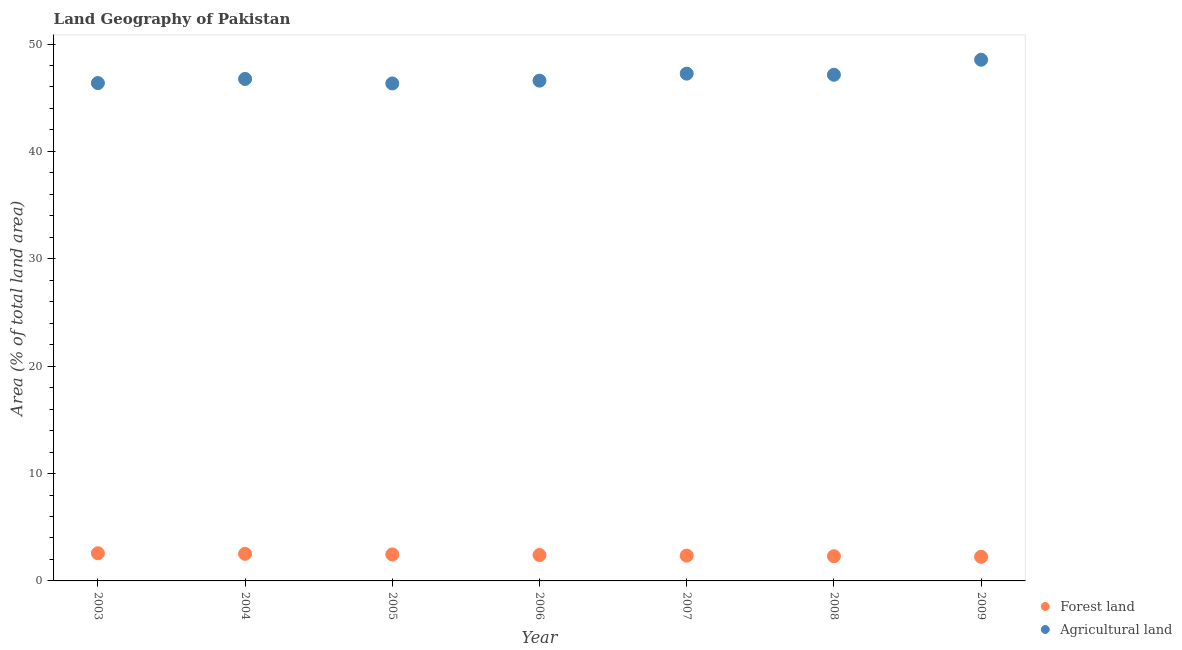How many different coloured dotlines are there?
Offer a very short reply. 2. Is the number of dotlines equal to the number of legend labels?
Make the answer very short. Yes. What is the percentage of land area under agriculture in 2006?
Ensure brevity in your answer.  46.59. Across all years, what is the maximum percentage of land area under agriculture?
Keep it short and to the point. 48.54. Across all years, what is the minimum percentage of land area under agriculture?
Make the answer very short. 46.33. What is the total percentage of land area under agriculture in the graph?
Keep it short and to the point. 328.94. What is the difference between the percentage of land area under agriculture in 2007 and that in 2009?
Your response must be concise. -1.3. What is the difference between the percentage of land area under agriculture in 2004 and the percentage of land area under forests in 2009?
Keep it short and to the point. 44.5. What is the average percentage of land area under forests per year?
Offer a terse response. 2.41. In the year 2009, what is the difference between the percentage of land area under forests and percentage of land area under agriculture?
Keep it short and to the point. -46.29. In how many years, is the percentage of land area under forests greater than 18 %?
Ensure brevity in your answer.  0. What is the ratio of the percentage of land area under agriculture in 2005 to that in 2006?
Your answer should be compact. 0.99. Is the difference between the percentage of land area under agriculture in 2003 and 2009 greater than the difference between the percentage of land area under forests in 2003 and 2009?
Ensure brevity in your answer.  No. What is the difference between the highest and the second highest percentage of land area under forests?
Your response must be concise. 0.06. What is the difference between the highest and the lowest percentage of land area under agriculture?
Your response must be concise. 2.21. Is the percentage of land area under agriculture strictly less than the percentage of land area under forests over the years?
Provide a succinct answer. No. How many dotlines are there?
Make the answer very short. 2. What is the difference between two consecutive major ticks on the Y-axis?
Your answer should be compact. 10. Does the graph contain any zero values?
Keep it short and to the point. No. Does the graph contain grids?
Ensure brevity in your answer.  No. What is the title of the graph?
Offer a terse response. Land Geography of Pakistan. Does "Age 65(male)" appear as one of the legend labels in the graph?
Make the answer very short. No. What is the label or title of the X-axis?
Your answer should be compact. Year. What is the label or title of the Y-axis?
Provide a short and direct response. Area (% of total land area). What is the Area (% of total land area) of Forest land in 2003?
Provide a short and direct response. 2.58. What is the Area (% of total land area) in Agricultural land in 2003?
Ensure brevity in your answer.  46.36. What is the Area (% of total land area) of Forest land in 2004?
Provide a short and direct response. 2.52. What is the Area (% of total land area) of Agricultural land in 2004?
Keep it short and to the point. 46.75. What is the Area (% of total land area) in Forest land in 2005?
Give a very brief answer. 2.47. What is the Area (% of total land area) of Agricultural land in 2005?
Your answer should be very brief. 46.33. What is the Area (% of total land area) in Forest land in 2006?
Ensure brevity in your answer.  2.41. What is the Area (% of total land area) of Agricultural land in 2006?
Ensure brevity in your answer.  46.59. What is the Area (% of total land area) in Forest land in 2007?
Provide a succinct answer. 2.36. What is the Area (% of total land area) in Agricultural land in 2007?
Offer a terse response. 47.24. What is the Area (% of total land area) of Forest land in 2008?
Offer a terse response. 2.3. What is the Area (% of total land area) in Agricultural land in 2008?
Your answer should be compact. 47.14. What is the Area (% of total land area) in Forest land in 2009?
Provide a short and direct response. 2.24. What is the Area (% of total land area) in Agricultural land in 2009?
Provide a succinct answer. 48.54. Across all years, what is the maximum Area (% of total land area) in Forest land?
Provide a succinct answer. 2.58. Across all years, what is the maximum Area (% of total land area) in Agricultural land?
Provide a short and direct response. 48.54. Across all years, what is the minimum Area (% of total land area) of Forest land?
Your response must be concise. 2.24. Across all years, what is the minimum Area (% of total land area) of Agricultural land?
Provide a succinct answer. 46.33. What is the total Area (% of total land area) of Forest land in the graph?
Your answer should be compact. 16.88. What is the total Area (% of total land area) in Agricultural land in the graph?
Keep it short and to the point. 328.94. What is the difference between the Area (% of total land area) in Forest land in 2003 and that in 2004?
Offer a very short reply. 0.06. What is the difference between the Area (% of total land area) of Agricultural land in 2003 and that in 2004?
Your answer should be very brief. -0.38. What is the difference between the Area (% of total land area) in Forest land in 2003 and that in 2005?
Ensure brevity in your answer.  0.11. What is the difference between the Area (% of total land area) of Agricultural land in 2003 and that in 2005?
Give a very brief answer. 0.04. What is the difference between the Area (% of total land area) in Forest land in 2003 and that in 2006?
Give a very brief answer. 0.17. What is the difference between the Area (% of total land area) of Agricultural land in 2003 and that in 2006?
Offer a very short reply. -0.22. What is the difference between the Area (% of total land area) in Forest land in 2003 and that in 2007?
Your answer should be very brief. 0.22. What is the difference between the Area (% of total land area) of Agricultural land in 2003 and that in 2007?
Your response must be concise. -0.88. What is the difference between the Area (% of total land area) in Forest land in 2003 and that in 2008?
Provide a short and direct response. 0.28. What is the difference between the Area (% of total land area) of Agricultural land in 2003 and that in 2008?
Ensure brevity in your answer.  -0.77. What is the difference between the Area (% of total land area) of Forest land in 2003 and that in 2009?
Make the answer very short. 0.33. What is the difference between the Area (% of total land area) in Agricultural land in 2003 and that in 2009?
Give a very brief answer. -2.17. What is the difference between the Area (% of total land area) in Forest land in 2004 and that in 2005?
Your response must be concise. 0.06. What is the difference between the Area (% of total land area) in Agricultural land in 2004 and that in 2005?
Provide a short and direct response. 0.42. What is the difference between the Area (% of total land area) in Forest land in 2004 and that in 2006?
Offer a terse response. 0.11. What is the difference between the Area (% of total land area) in Agricultural land in 2004 and that in 2006?
Make the answer very short. 0.16. What is the difference between the Area (% of total land area) of Forest land in 2004 and that in 2007?
Make the answer very short. 0.17. What is the difference between the Area (% of total land area) in Agricultural land in 2004 and that in 2007?
Provide a short and direct response. -0.5. What is the difference between the Area (% of total land area) of Forest land in 2004 and that in 2008?
Your response must be concise. 0.22. What is the difference between the Area (% of total land area) of Agricultural land in 2004 and that in 2008?
Make the answer very short. -0.39. What is the difference between the Area (% of total land area) of Forest land in 2004 and that in 2009?
Your answer should be compact. 0.28. What is the difference between the Area (% of total land area) of Agricultural land in 2004 and that in 2009?
Provide a succinct answer. -1.79. What is the difference between the Area (% of total land area) of Forest land in 2005 and that in 2006?
Give a very brief answer. 0.06. What is the difference between the Area (% of total land area) in Agricultural land in 2005 and that in 2006?
Offer a very short reply. -0.26. What is the difference between the Area (% of total land area) of Forest land in 2005 and that in 2007?
Provide a short and direct response. 0.11. What is the difference between the Area (% of total land area) of Agricultural land in 2005 and that in 2007?
Offer a terse response. -0.91. What is the difference between the Area (% of total land area) of Forest land in 2005 and that in 2008?
Offer a terse response. 0.17. What is the difference between the Area (% of total land area) of Agricultural land in 2005 and that in 2008?
Offer a terse response. -0.81. What is the difference between the Area (% of total land area) in Forest land in 2005 and that in 2009?
Your response must be concise. 0.22. What is the difference between the Area (% of total land area) of Agricultural land in 2005 and that in 2009?
Offer a very short reply. -2.21. What is the difference between the Area (% of total land area) in Forest land in 2006 and that in 2007?
Keep it short and to the point. 0.06. What is the difference between the Area (% of total land area) in Agricultural land in 2006 and that in 2007?
Provide a succinct answer. -0.65. What is the difference between the Area (% of total land area) of Forest land in 2006 and that in 2008?
Provide a short and direct response. 0.11. What is the difference between the Area (% of total land area) in Agricultural land in 2006 and that in 2008?
Keep it short and to the point. -0.55. What is the difference between the Area (% of total land area) in Forest land in 2006 and that in 2009?
Give a very brief answer. 0.17. What is the difference between the Area (% of total land area) of Agricultural land in 2006 and that in 2009?
Offer a terse response. -1.95. What is the difference between the Area (% of total land area) of Forest land in 2007 and that in 2008?
Make the answer very short. 0.06. What is the difference between the Area (% of total land area) in Agricultural land in 2007 and that in 2008?
Make the answer very short. 0.1. What is the difference between the Area (% of total land area) in Forest land in 2007 and that in 2009?
Offer a terse response. 0.11. What is the difference between the Area (% of total land area) in Agricultural land in 2007 and that in 2009?
Offer a terse response. -1.3. What is the difference between the Area (% of total land area) of Forest land in 2008 and that in 2009?
Your answer should be compact. 0.06. What is the difference between the Area (% of total land area) of Agricultural land in 2008 and that in 2009?
Make the answer very short. -1.4. What is the difference between the Area (% of total land area) in Forest land in 2003 and the Area (% of total land area) in Agricultural land in 2004?
Keep it short and to the point. -44.17. What is the difference between the Area (% of total land area) of Forest land in 2003 and the Area (% of total land area) of Agricultural land in 2005?
Ensure brevity in your answer.  -43.75. What is the difference between the Area (% of total land area) of Forest land in 2003 and the Area (% of total land area) of Agricultural land in 2006?
Make the answer very short. -44.01. What is the difference between the Area (% of total land area) of Forest land in 2003 and the Area (% of total land area) of Agricultural land in 2007?
Your answer should be very brief. -44.66. What is the difference between the Area (% of total land area) in Forest land in 2003 and the Area (% of total land area) in Agricultural land in 2008?
Provide a short and direct response. -44.56. What is the difference between the Area (% of total land area) in Forest land in 2003 and the Area (% of total land area) in Agricultural land in 2009?
Your response must be concise. -45.96. What is the difference between the Area (% of total land area) in Forest land in 2004 and the Area (% of total land area) in Agricultural land in 2005?
Offer a terse response. -43.8. What is the difference between the Area (% of total land area) of Forest land in 2004 and the Area (% of total land area) of Agricultural land in 2006?
Your answer should be compact. -44.06. What is the difference between the Area (% of total land area) in Forest land in 2004 and the Area (% of total land area) in Agricultural land in 2007?
Your response must be concise. -44.72. What is the difference between the Area (% of total land area) in Forest land in 2004 and the Area (% of total land area) in Agricultural land in 2008?
Your answer should be very brief. -44.61. What is the difference between the Area (% of total land area) of Forest land in 2004 and the Area (% of total land area) of Agricultural land in 2009?
Your response must be concise. -46.01. What is the difference between the Area (% of total land area) in Forest land in 2005 and the Area (% of total land area) in Agricultural land in 2006?
Offer a very short reply. -44.12. What is the difference between the Area (% of total land area) of Forest land in 2005 and the Area (% of total land area) of Agricultural land in 2007?
Your response must be concise. -44.77. What is the difference between the Area (% of total land area) of Forest land in 2005 and the Area (% of total land area) of Agricultural land in 2008?
Give a very brief answer. -44.67. What is the difference between the Area (% of total land area) in Forest land in 2005 and the Area (% of total land area) in Agricultural land in 2009?
Your answer should be very brief. -46.07. What is the difference between the Area (% of total land area) of Forest land in 2006 and the Area (% of total land area) of Agricultural land in 2007?
Offer a very short reply. -44.83. What is the difference between the Area (% of total land area) in Forest land in 2006 and the Area (% of total land area) in Agricultural land in 2008?
Offer a very short reply. -44.73. What is the difference between the Area (% of total land area) in Forest land in 2006 and the Area (% of total land area) in Agricultural land in 2009?
Provide a succinct answer. -46.13. What is the difference between the Area (% of total land area) of Forest land in 2007 and the Area (% of total land area) of Agricultural land in 2008?
Offer a very short reply. -44.78. What is the difference between the Area (% of total land area) of Forest land in 2007 and the Area (% of total land area) of Agricultural land in 2009?
Make the answer very short. -46.18. What is the difference between the Area (% of total land area) in Forest land in 2008 and the Area (% of total land area) in Agricultural land in 2009?
Ensure brevity in your answer.  -46.24. What is the average Area (% of total land area) of Forest land per year?
Provide a succinct answer. 2.41. What is the average Area (% of total land area) in Agricultural land per year?
Your response must be concise. 46.99. In the year 2003, what is the difference between the Area (% of total land area) of Forest land and Area (% of total land area) of Agricultural land?
Offer a terse response. -43.78. In the year 2004, what is the difference between the Area (% of total land area) in Forest land and Area (% of total land area) in Agricultural land?
Your answer should be very brief. -44.22. In the year 2005, what is the difference between the Area (% of total land area) in Forest land and Area (% of total land area) in Agricultural land?
Offer a terse response. -43.86. In the year 2006, what is the difference between the Area (% of total land area) of Forest land and Area (% of total land area) of Agricultural land?
Your response must be concise. -44.18. In the year 2007, what is the difference between the Area (% of total land area) of Forest land and Area (% of total land area) of Agricultural land?
Offer a very short reply. -44.89. In the year 2008, what is the difference between the Area (% of total land area) of Forest land and Area (% of total land area) of Agricultural land?
Your answer should be compact. -44.84. In the year 2009, what is the difference between the Area (% of total land area) of Forest land and Area (% of total land area) of Agricultural land?
Provide a succinct answer. -46.29. What is the ratio of the Area (% of total land area) in Forest land in 2003 to that in 2005?
Offer a very short reply. 1.04. What is the ratio of the Area (% of total land area) of Agricultural land in 2003 to that in 2005?
Provide a short and direct response. 1. What is the ratio of the Area (% of total land area) of Forest land in 2003 to that in 2006?
Keep it short and to the point. 1.07. What is the ratio of the Area (% of total land area) in Forest land in 2003 to that in 2007?
Offer a terse response. 1.09. What is the ratio of the Area (% of total land area) of Agricultural land in 2003 to that in 2007?
Your response must be concise. 0.98. What is the ratio of the Area (% of total land area) in Forest land in 2003 to that in 2008?
Keep it short and to the point. 1.12. What is the ratio of the Area (% of total land area) of Agricultural land in 2003 to that in 2008?
Provide a short and direct response. 0.98. What is the ratio of the Area (% of total land area) in Forest land in 2003 to that in 2009?
Your answer should be compact. 1.15. What is the ratio of the Area (% of total land area) of Agricultural land in 2003 to that in 2009?
Your answer should be compact. 0.96. What is the ratio of the Area (% of total land area) in Forest land in 2004 to that in 2005?
Provide a succinct answer. 1.02. What is the ratio of the Area (% of total land area) in Forest land in 2004 to that in 2006?
Your answer should be compact. 1.05. What is the ratio of the Area (% of total land area) of Agricultural land in 2004 to that in 2006?
Provide a succinct answer. 1. What is the ratio of the Area (% of total land area) in Forest land in 2004 to that in 2007?
Offer a very short reply. 1.07. What is the ratio of the Area (% of total land area) in Forest land in 2004 to that in 2008?
Keep it short and to the point. 1.1. What is the ratio of the Area (% of total land area) in Agricultural land in 2004 to that in 2008?
Provide a succinct answer. 0.99. What is the ratio of the Area (% of total land area) of Forest land in 2004 to that in 2009?
Provide a short and direct response. 1.12. What is the ratio of the Area (% of total land area) in Agricultural land in 2004 to that in 2009?
Ensure brevity in your answer.  0.96. What is the ratio of the Area (% of total land area) of Forest land in 2005 to that in 2006?
Offer a very short reply. 1.02. What is the ratio of the Area (% of total land area) in Agricultural land in 2005 to that in 2006?
Give a very brief answer. 0.99. What is the ratio of the Area (% of total land area) in Forest land in 2005 to that in 2007?
Your answer should be compact. 1.05. What is the ratio of the Area (% of total land area) in Agricultural land in 2005 to that in 2007?
Ensure brevity in your answer.  0.98. What is the ratio of the Area (% of total land area) in Forest land in 2005 to that in 2008?
Offer a terse response. 1.07. What is the ratio of the Area (% of total land area) in Agricultural land in 2005 to that in 2008?
Give a very brief answer. 0.98. What is the ratio of the Area (% of total land area) in Forest land in 2005 to that in 2009?
Give a very brief answer. 1.1. What is the ratio of the Area (% of total land area) in Agricultural land in 2005 to that in 2009?
Give a very brief answer. 0.95. What is the ratio of the Area (% of total land area) in Forest land in 2006 to that in 2007?
Give a very brief answer. 1.02. What is the ratio of the Area (% of total land area) of Agricultural land in 2006 to that in 2007?
Provide a short and direct response. 0.99. What is the ratio of the Area (% of total land area) in Forest land in 2006 to that in 2008?
Your response must be concise. 1.05. What is the ratio of the Area (% of total land area) of Agricultural land in 2006 to that in 2008?
Your answer should be very brief. 0.99. What is the ratio of the Area (% of total land area) in Forest land in 2006 to that in 2009?
Your answer should be compact. 1.07. What is the ratio of the Area (% of total land area) of Agricultural land in 2006 to that in 2009?
Your answer should be very brief. 0.96. What is the ratio of the Area (% of total land area) of Forest land in 2007 to that in 2008?
Make the answer very short. 1.02. What is the ratio of the Area (% of total land area) in Agricultural land in 2007 to that in 2008?
Offer a very short reply. 1. What is the ratio of the Area (% of total land area) in Forest land in 2007 to that in 2009?
Offer a terse response. 1.05. What is the ratio of the Area (% of total land area) of Agricultural land in 2007 to that in 2009?
Provide a short and direct response. 0.97. What is the ratio of the Area (% of total land area) in Forest land in 2008 to that in 2009?
Provide a short and direct response. 1.02. What is the ratio of the Area (% of total land area) in Agricultural land in 2008 to that in 2009?
Offer a terse response. 0.97. What is the difference between the highest and the second highest Area (% of total land area) in Forest land?
Offer a terse response. 0.06. What is the difference between the highest and the second highest Area (% of total land area) in Agricultural land?
Your answer should be very brief. 1.3. What is the difference between the highest and the lowest Area (% of total land area) in Forest land?
Your answer should be very brief. 0.33. What is the difference between the highest and the lowest Area (% of total land area) in Agricultural land?
Give a very brief answer. 2.21. 